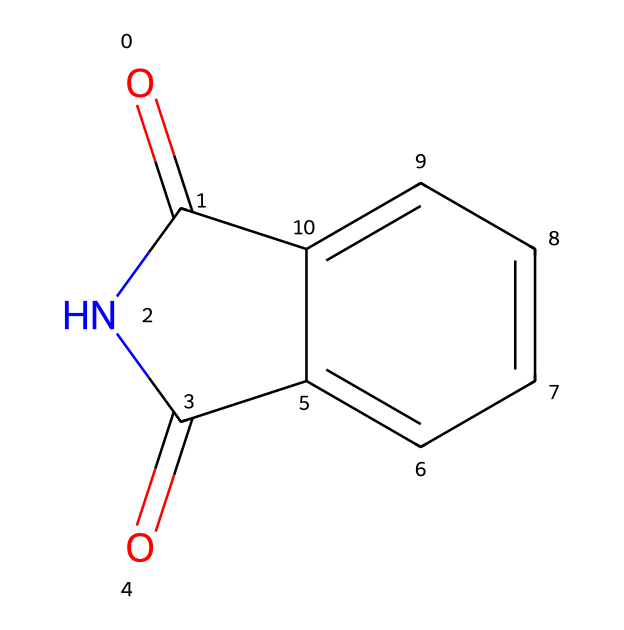How many carbon atoms are in phthalimide? The SMILES representation shows the structure with two distinctive carbonyl groups and a benzene ring, which collectively indicate 8 carbon atoms.
Answer: 8 What is the functional group present in phthalimide? The structure contains two carbonyl groups (C=O) and a nitrogen atom (N) as part of the imide functionality. This combination defines the imide functional group.
Answer: imide How many nitrogen atoms are in the molecule? By examining the SMILES, the nitrogen is explicitly represented, indicating that there is one nitrogen atom in the structure of phthalimide.
Answer: 1 Does phthalimide have any stereocenters? The structure does not have any carbon atoms bonded to four different substituents, indicating that there are no stereocenters present in phthalimide.
Answer: no Which part of the molecule contributes to its potential use in cosmetics? The imide functional group and the presence of the aromatic ring may contribute to its stability and compatibility with skin, making it suitable for use in cosmetic formulations.
Answer: imide and aromatic ring What type of bond connects the nitrogen atom to the carbonyl groups in phthalimide? The bond connecting nitrogen to the carbonyl groups is a double bond, which is characteristic of the imide structure, indicating a resonance stability in the molecule.
Answer: double bond Is phthalimide a cyclic compound? The structure indicates the presence of a ring system due to the connection between the two carbonyl groups and the nitrogen atom, forming a cyclic structure with a benzene component.
Answer: yes 